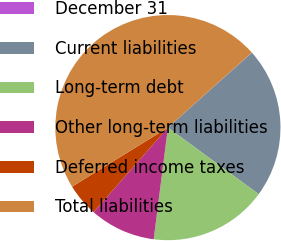<chart> <loc_0><loc_0><loc_500><loc_500><pie_chart><fcel>December 31<fcel>Current liabilities<fcel>Long-term debt<fcel>Other long-term liabilities<fcel>Deferred income taxes<fcel>Total liabilities<nl><fcel>0.03%<fcel>21.66%<fcel>16.95%<fcel>9.46%<fcel>4.74%<fcel>47.17%<nl></chart> 